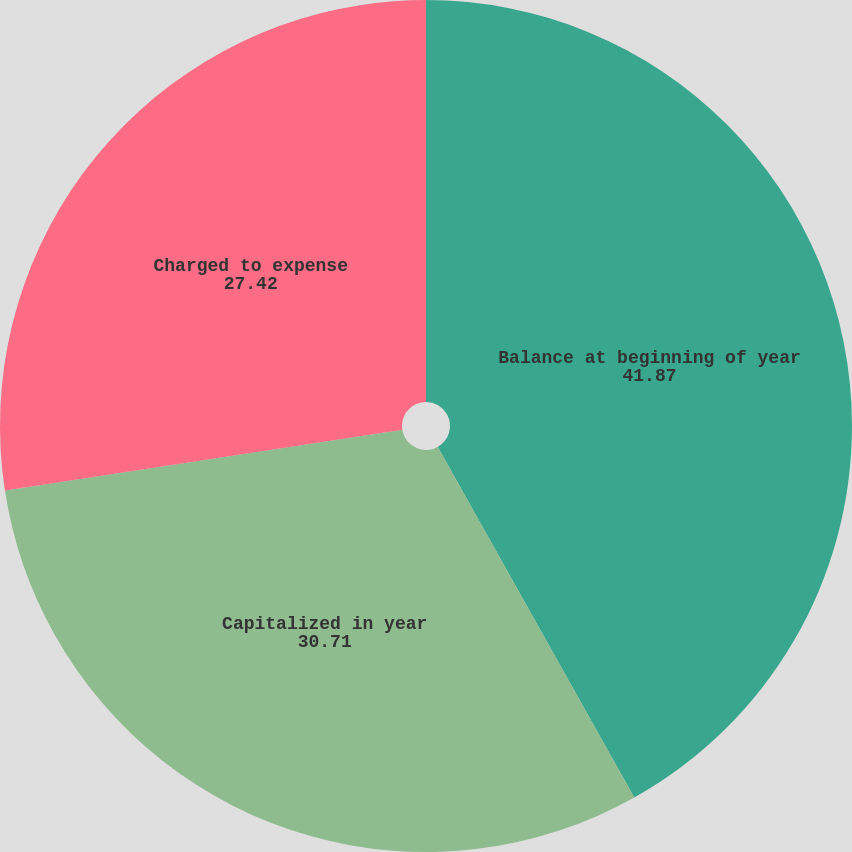Convert chart. <chart><loc_0><loc_0><loc_500><loc_500><pie_chart><fcel>Balance at beginning of year<fcel>Capitalized in year<fcel>Charged to expense<nl><fcel>41.87%<fcel>30.71%<fcel>27.42%<nl></chart> 